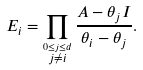<formula> <loc_0><loc_0><loc_500><loc_500>E _ { i } = \prod _ { \stackrel { 0 \leq j \leq d } { j \neq i } } \frac { A - \theta _ { j } I } { \theta _ { i } - \theta _ { j } } .</formula> 